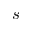<formula> <loc_0><loc_0><loc_500><loc_500>s</formula> 